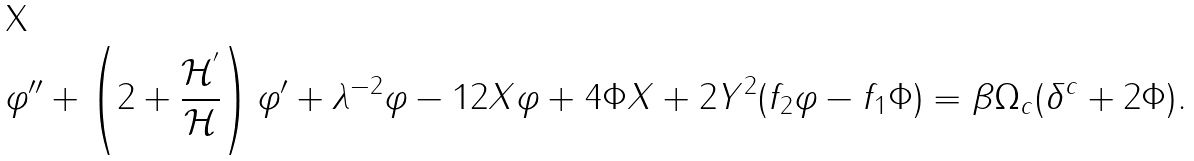Convert formula to latex. <formula><loc_0><loc_0><loc_500><loc_500>\varphi ^ { \prime \prime } + \left ( 2 + \frac { { \mathcal { H } } ^ { ^ { \prime } } } { { \mathcal { H } } } \right ) \varphi ^ { \prime } + \lambda ^ { - 2 } \varphi - 1 2 X \varphi + 4 \Phi X + 2 Y ^ { 2 } ( f _ { 2 } \varphi - f _ { 1 } \Phi ) = \beta \Omega _ { c } ( \delta ^ { c } + 2 \Phi ) .</formula> 